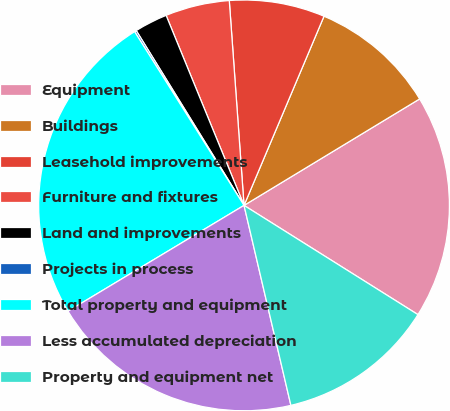Convert chart. <chart><loc_0><loc_0><loc_500><loc_500><pie_chart><fcel>Equipment<fcel>Buildings<fcel>Leasehold improvements<fcel>Furniture and fixtures<fcel>Land and improvements<fcel>Projects in process<fcel>Total property and equipment<fcel>Less accumulated depreciation<fcel>Property and equipment net<nl><fcel>17.6%<fcel>9.96%<fcel>7.51%<fcel>5.05%<fcel>2.6%<fcel>0.15%<fcel>24.67%<fcel>20.05%<fcel>12.41%<nl></chart> 